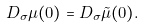<formula> <loc_0><loc_0><loc_500><loc_500>D _ { \sigma } \mu ( 0 ) = D _ { \sigma } \tilde { \mu } ( 0 ) .</formula> 